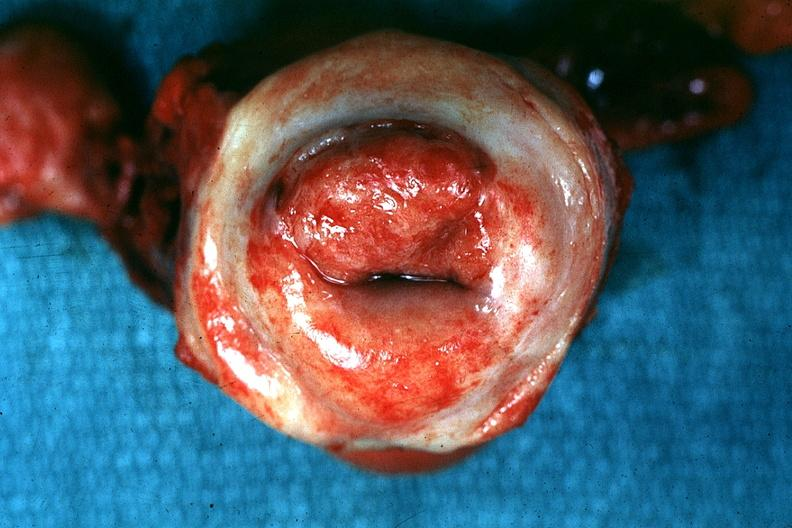what labeled as invasive?
Answer the question using a single word or phrase. Excellent example tumor 